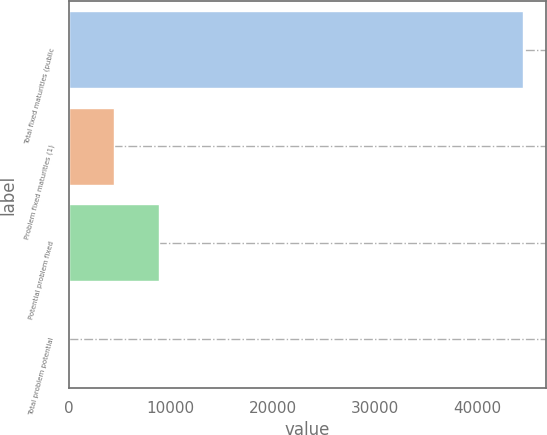<chart> <loc_0><loc_0><loc_500><loc_500><bar_chart><fcel>Total fixed maturities (public<fcel>Problem fixed maturities (1)<fcel>Potential problem fixed<fcel>Total problem potential<nl><fcel>44485.9<fcel>4449.71<fcel>8898.18<fcel>1.24<nl></chart> 